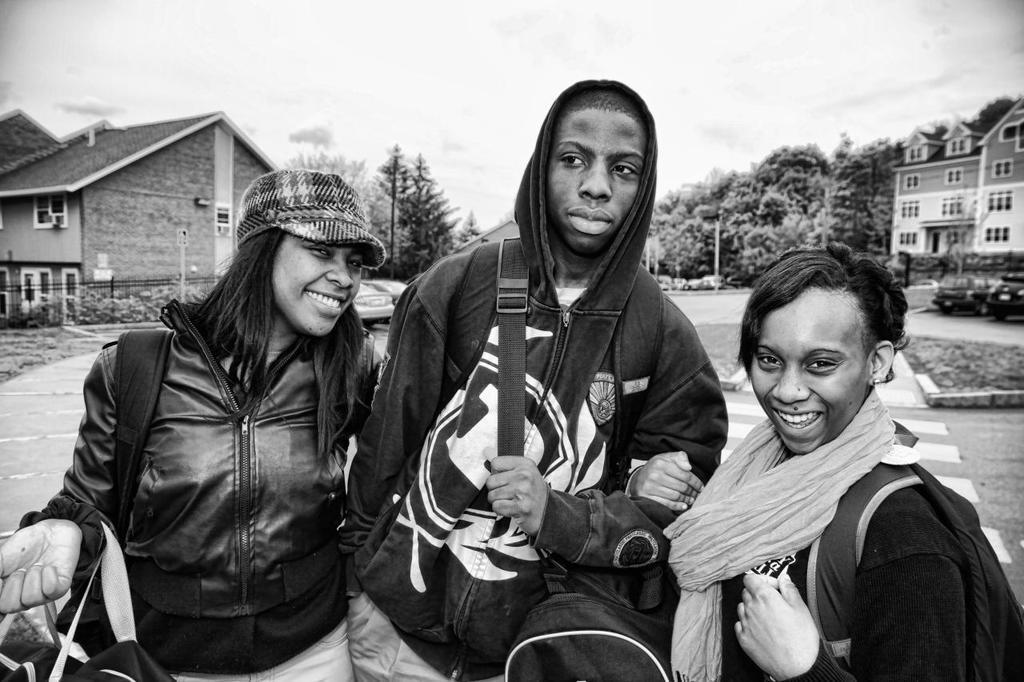Please provide a concise description of this image. This is a black and white image. In this image we can see people wearing bags and among them two people are smiling. In the background we can see trees, plants, houses, cars and fence. 